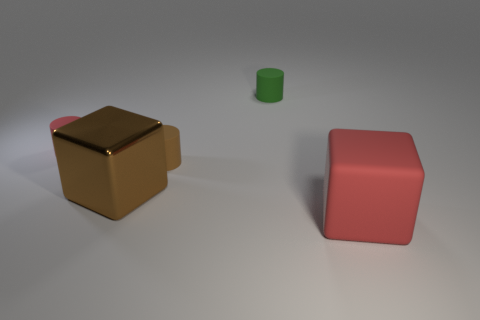Subtract all red cylinders. How many cylinders are left? 2 Add 5 green rubber cylinders. How many objects exist? 10 Subtract all brown cylinders. How many cylinders are left? 2 Add 4 big purple metal cylinders. How many big purple metal cylinders exist? 4 Subtract 0 green spheres. How many objects are left? 5 Subtract all cylinders. How many objects are left? 2 Subtract 2 cubes. How many cubes are left? 0 Subtract all gray cylinders. Subtract all gray spheres. How many cylinders are left? 3 Subtract all green cylinders. How many brown cubes are left? 1 Subtract all small purple blocks. Subtract all large red blocks. How many objects are left? 4 